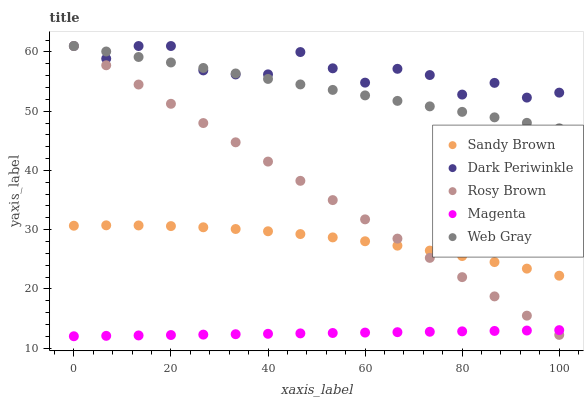Does Magenta have the minimum area under the curve?
Answer yes or no. Yes. Does Dark Periwinkle have the maximum area under the curve?
Answer yes or no. Yes. Does Rosy Brown have the minimum area under the curve?
Answer yes or no. No. Does Rosy Brown have the maximum area under the curve?
Answer yes or no. No. Is Magenta the smoothest?
Answer yes or no. Yes. Is Dark Periwinkle the roughest?
Answer yes or no. Yes. Is Rosy Brown the smoothest?
Answer yes or no. No. Is Rosy Brown the roughest?
Answer yes or no. No. Does Magenta have the lowest value?
Answer yes or no. Yes. Does Rosy Brown have the lowest value?
Answer yes or no. No. Does Dark Periwinkle have the highest value?
Answer yes or no. Yes. Does Magenta have the highest value?
Answer yes or no. No. Is Sandy Brown less than Dark Periwinkle?
Answer yes or no. Yes. Is Web Gray greater than Sandy Brown?
Answer yes or no. Yes. Does Rosy Brown intersect Web Gray?
Answer yes or no. Yes. Is Rosy Brown less than Web Gray?
Answer yes or no. No. Is Rosy Brown greater than Web Gray?
Answer yes or no. No. Does Sandy Brown intersect Dark Periwinkle?
Answer yes or no. No. 